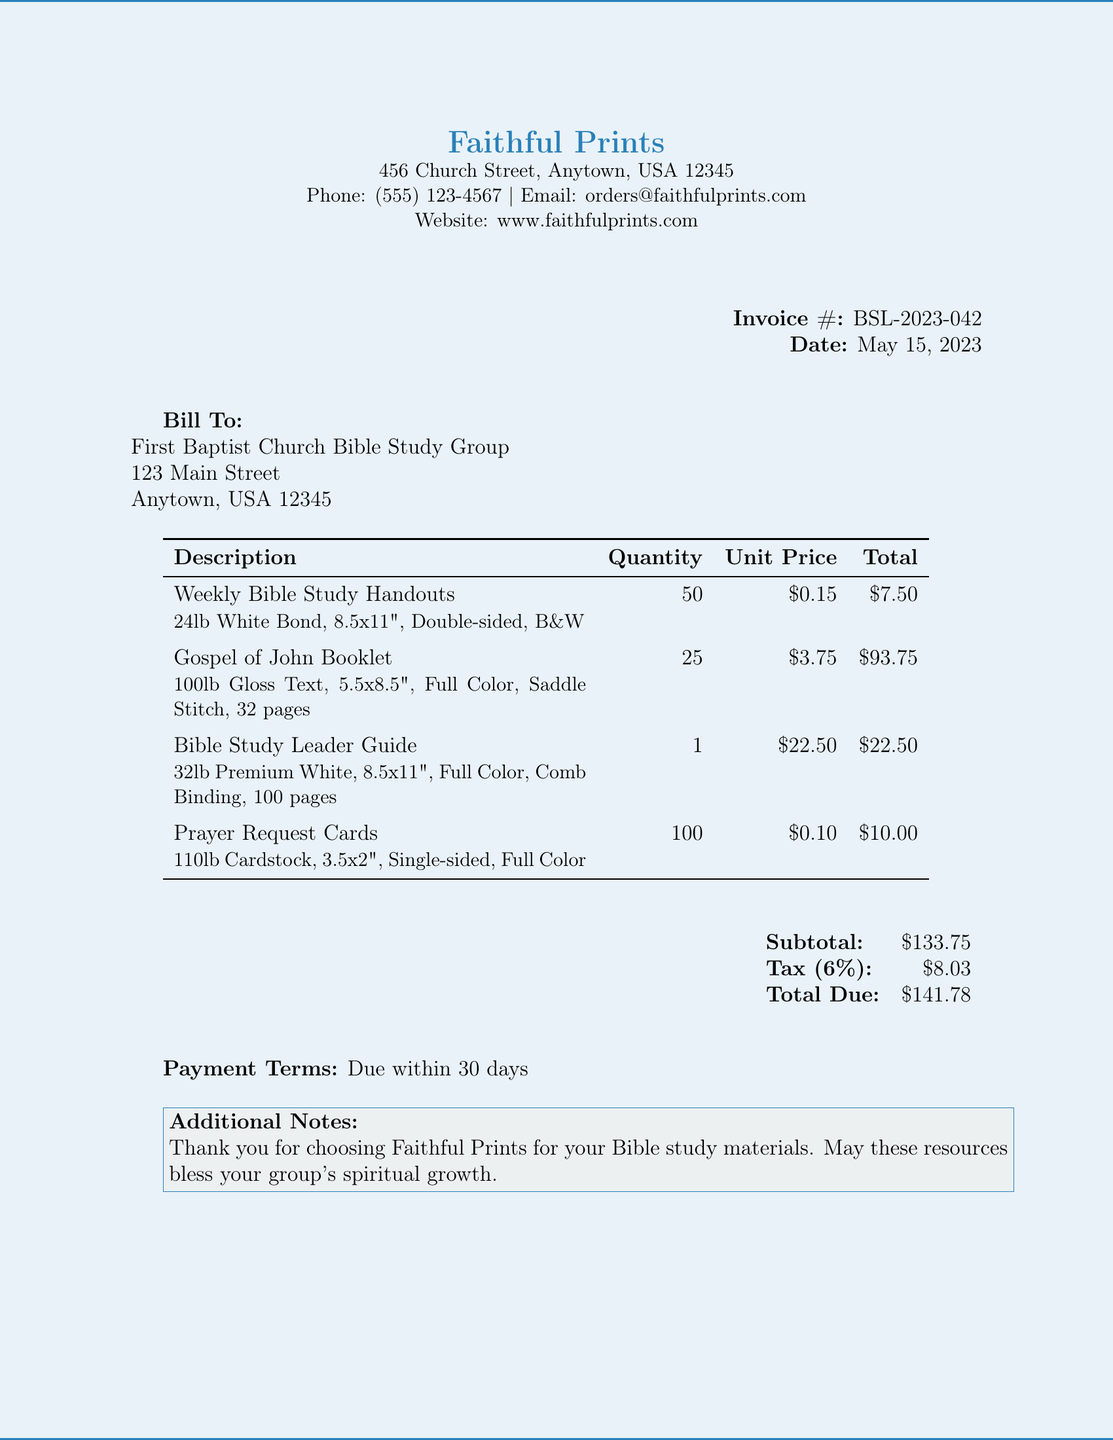What is the invoice number? The invoice number is a unique identifier for this document, listed clearly in the header.
Answer: BSL-2023-042 What is the date of the invoice? The date is mentioned in the header section of the invoice.
Answer: May 15, 2023 Who is the client? This refers to the organization or individual the invoice is addressed to, detailed in the billing section.
Answer: First Baptist Church Bible Study Group How many Weekly Bible Study Handouts were ordered? This information is available in the items table, specifying the quantity ordered for this item.
Answer: 50 What is the total amount due? The total amount due is calculated as the sum of the subtotal and tax, displayed in the financial summary section.
Answer: $141.78 What type of binding was used for the Bible Study Leader Guide? This detail is listed under the specific item description, highlighting the binding method chosen.
Answer: Comb Binding What is the paper type for the Prayer Request Cards? The specific paper type for each item is provided in the itemized list within the document.
Answer: 110lb Cardstock What are the payment terms? Payment terms dictate when payment is expected, and this is noted towards the end of the document.
Answer: Due within 30 days What is the subtotal for the printing services? The subtotal represents the total cost of items before tax, as shown in the financial summary.
Answer: $133.75 